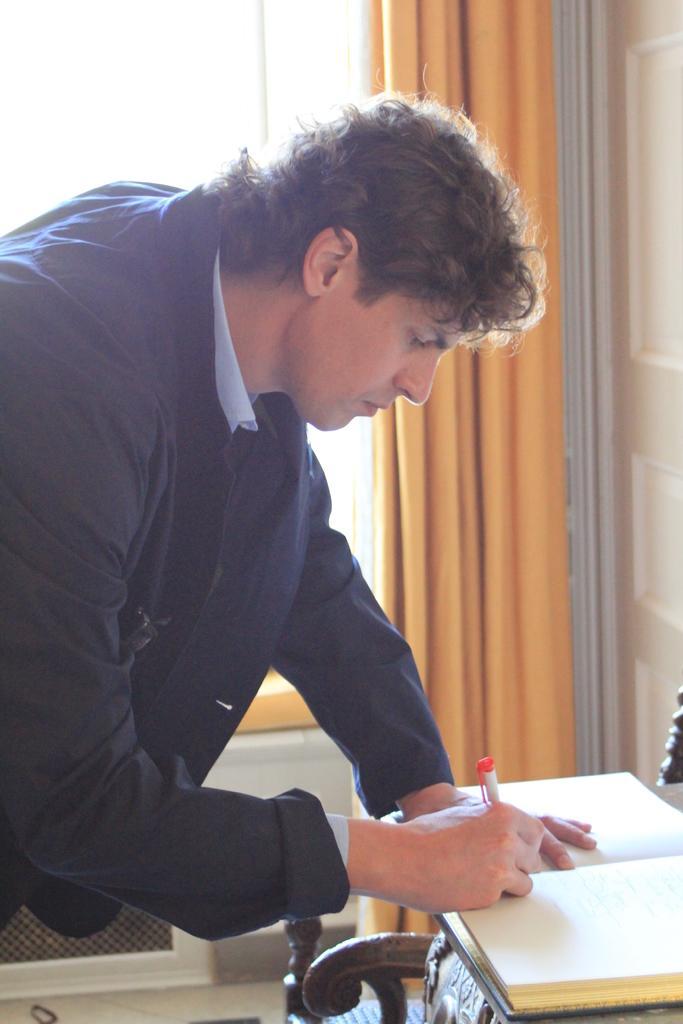What is the person in the image doing? The person is writing in a book. Where is the book placed in the image? The book is placed on a table. What can be seen through the window in the image? The information provided does not specify what can be seen through the window. What type of window treatment is present in the image? There is a curtain associated with the window. What type of silver boot can be seen on the person's foot in the image? There is no silver boot visible on the person's foot in the image. 